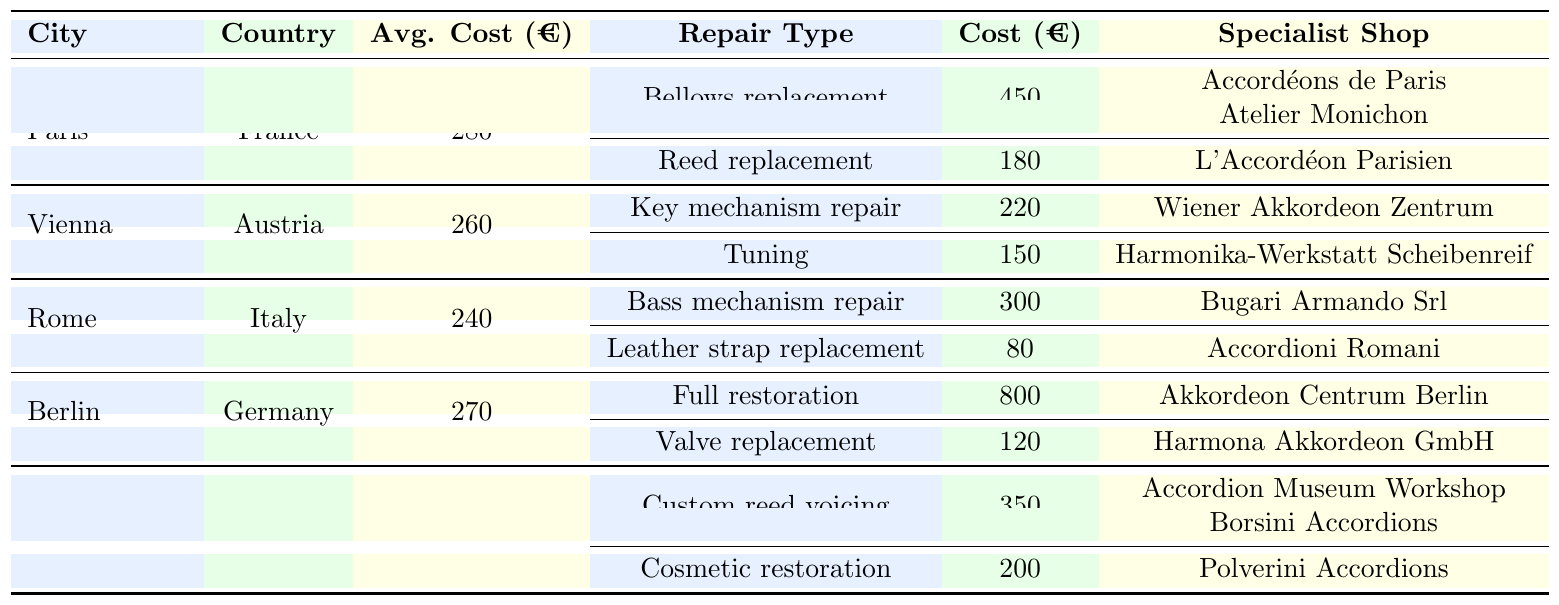What is the average repair cost in Berlin? The table indicates that the average repair cost in Berlin is €270, directly stated in the table.
Answer: 270 Which city has the highest average repair cost? By comparing the average repair costs of each city (Paris: €280, Vienna: €260, Rome: €240, Berlin: €270, Castelfidardo: €230), Paris has the highest average repair cost at €280.
Answer: Paris What is the cost of a full restoration in Berlin? The table shows that the cost of a full restoration in Berlin is €800, listed under the repair types for the city.
Answer: 800 How many specialist shops offer bellows replacement in Paris? In Paris, there are two specialist shops listed for bellows replacement: Accordéons de Paris and Atelier Monichon. Therefore, the count is two.
Answer: 2 What is the total cost of repairing both the bass mechanism and leather strap in Rome? The cost for bass mechanism repair in Rome is €300, and for leather strap replacement, it is €80. Summing these gives €300 + €80 = €380.
Answer: 380 Is the waiting time for tuning in Vienna longer than the waiting time for reed replacement in Paris? The waiting time for tuning in Vienna is 5 days, while the waiting time for reed replacement in Paris is 7 days. So, 5 days is not longer than 7 days, making the statement false.
Answer: No Which city has the lowest average repair cost? By assessing the average costs (Paris: €280, Vienna: €260, Rome: €240, Berlin: €270, Castelfidardo: €230), Castelfidardo has the lowest average repair cost of €230.
Answer: Castelfidardo How much do specialist shops charge for a cosmetic restoration in Castelfidardo? The cost for cosmetic restoration in Castelfidardo is €200, as stated in the repair types for that city.
Answer: 200 If you need to replace your reeds in Paris, how much would it cost? The table specifies that the cost for reed replacement in Paris is €180, which is clearly stated.
Answer: 180 What is the average repair cost across all the listed cities? To find the average, sum the average costs of all cities (€280 + €260 + €240 + €270 + €230 = €1280) and divide by the number of cities (5), resulting in €1280 / 5 = €256.
Answer: 256 